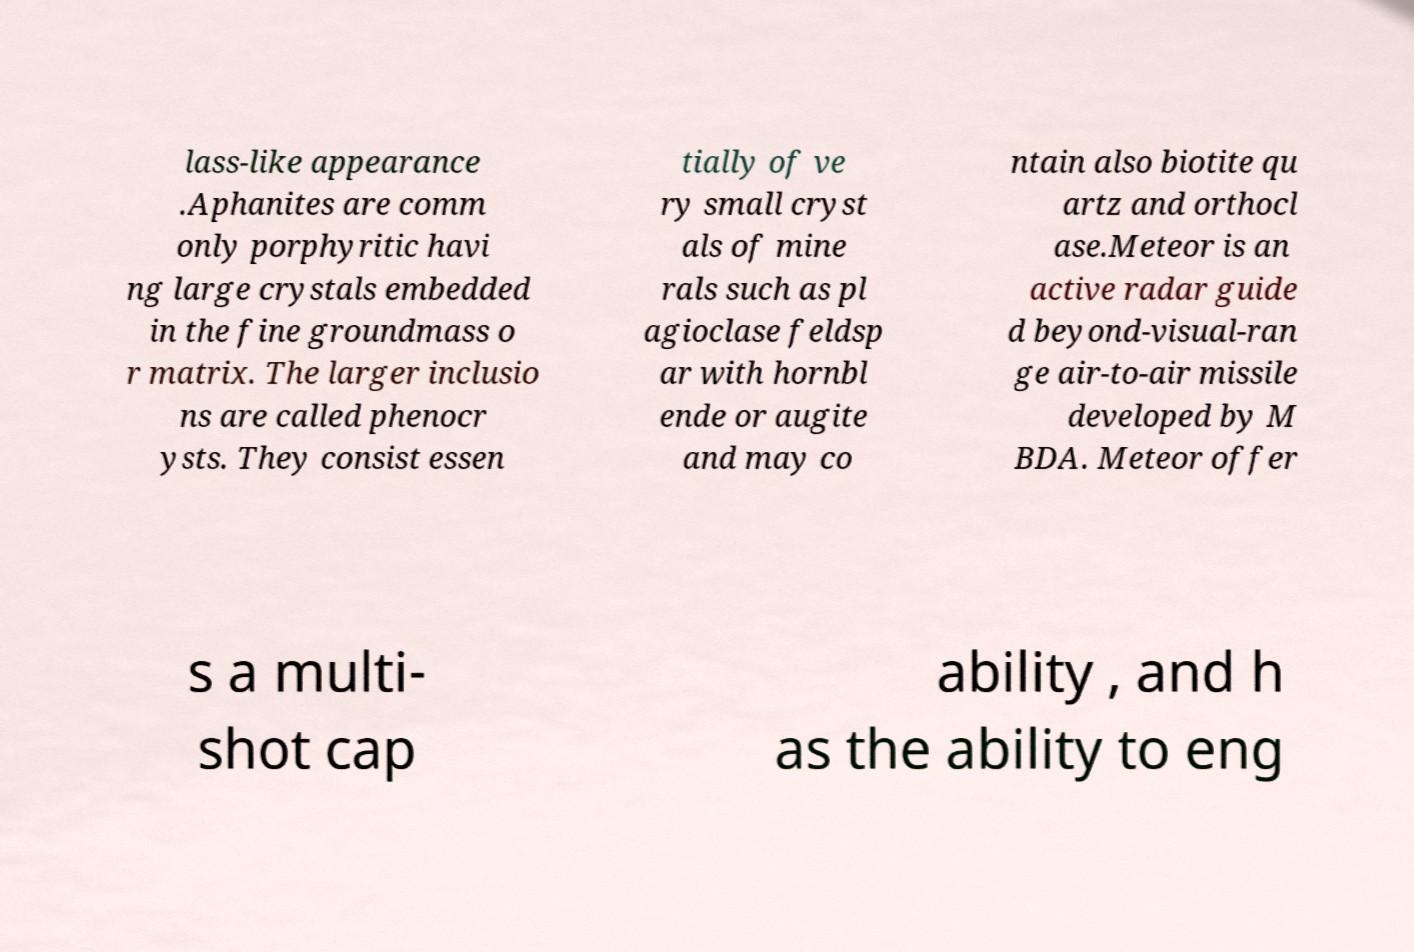Could you extract and type out the text from this image? lass-like appearance .Aphanites are comm only porphyritic havi ng large crystals embedded in the fine groundmass o r matrix. The larger inclusio ns are called phenocr ysts. They consist essen tially of ve ry small cryst als of mine rals such as pl agioclase feldsp ar with hornbl ende or augite and may co ntain also biotite qu artz and orthocl ase.Meteor is an active radar guide d beyond-visual-ran ge air-to-air missile developed by M BDA. Meteor offer s a multi- shot cap ability , and h as the ability to eng 